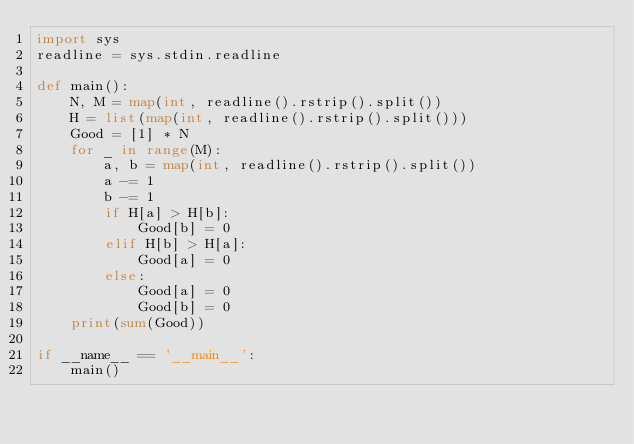Convert code to text. <code><loc_0><loc_0><loc_500><loc_500><_Python_>import sys
readline = sys.stdin.readline

def main():
    N, M = map(int, readline().rstrip().split())
    H = list(map(int, readline().rstrip().split()))
    Good = [1] * N
    for _ in range(M):
        a, b = map(int, readline().rstrip().split())
        a -= 1
        b -= 1
        if H[a] > H[b]:
            Good[b] = 0
        elif H[b] > H[a]:
            Good[a] = 0
        else:
            Good[a] = 0
            Good[b] = 0
    print(sum(Good))

if __name__ == '__main__':
    main()</code> 